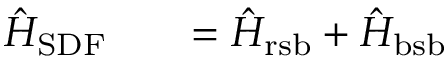Convert formula to latex. <formula><loc_0><loc_0><loc_500><loc_500>\begin{array} { r l r } { \hat { H } _ { S D F } } & { = \hat { H } _ { r s b } + \hat { H } _ { b s b } } \end{array}</formula> 